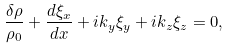Convert formula to latex. <formula><loc_0><loc_0><loc_500><loc_500>\frac { \delta \rho } { \rho _ { 0 } } + \frac { d \xi _ { x } } { d x } + i k _ { y } \xi _ { y } + i k _ { z } \xi _ { z } = 0 ,</formula> 